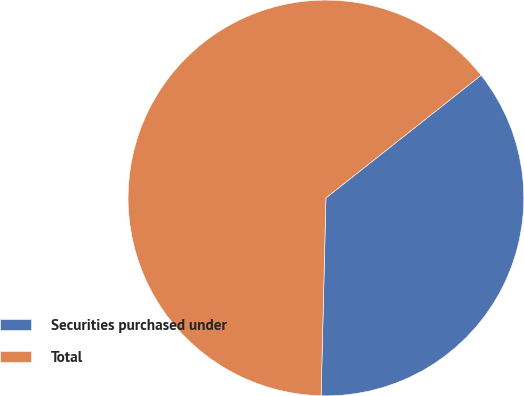Convert chart to OTSL. <chart><loc_0><loc_0><loc_500><loc_500><pie_chart><fcel>Securities purchased under<fcel>Total<nl><fcel>36.04%<fcel>63.96%<nl></chart> 